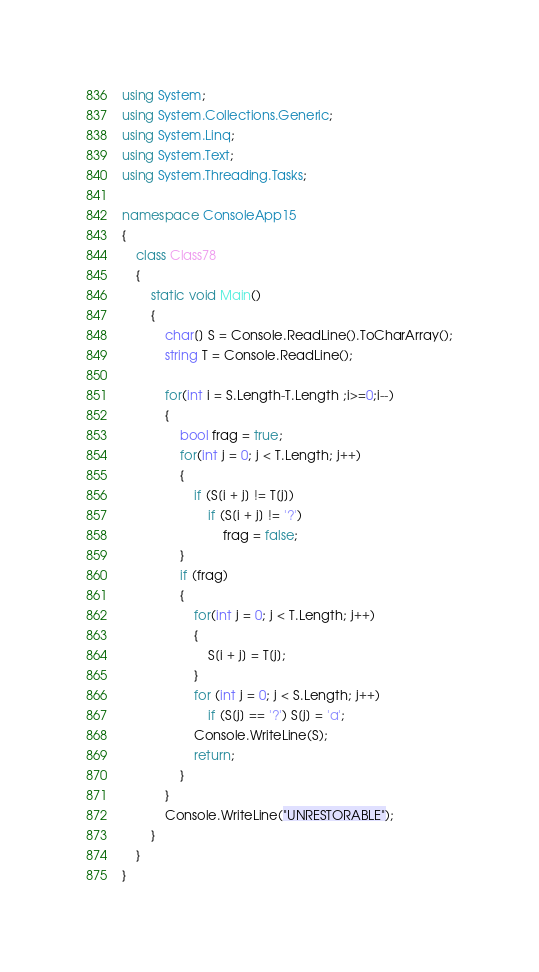<code> <loc_0><loc_0><loc_500><loc_500><_C#_>using System;
using System.Collections.Generic;
using System.Linq;
using System.Text;
using System.Threading.Tasks;

namespace ConsoleApp15
{
    class Class78
    {
        static void Main()
        {
            char[] S = Console.ReadLine().ToCharArray();
            string T = Console.ReadLine();

            for(int i = S.Length-T.Length ;i>=0;i--)
            {
                bool frag = true;
                for(int j = 0; j < T.Length; j++)
                {
                    if (S[i + j] != T[j])
                        if (S[i + j] != '?')
                            frag = false;
                }
                if (frag)
                {
                    for(int j = 0; j < T.Length; j++)
                    {
                        S[i + j] = T[j];
                    }
                    for (int j = 0; j < S.Length; j++)
                        if (S[j] == '?') S[j] = 'a';
                    Console.WriteLine(S);
                    return;
                }
            }
            Console.WriteLine("UNRESTORABLE");
        }
    }
}
</code> 